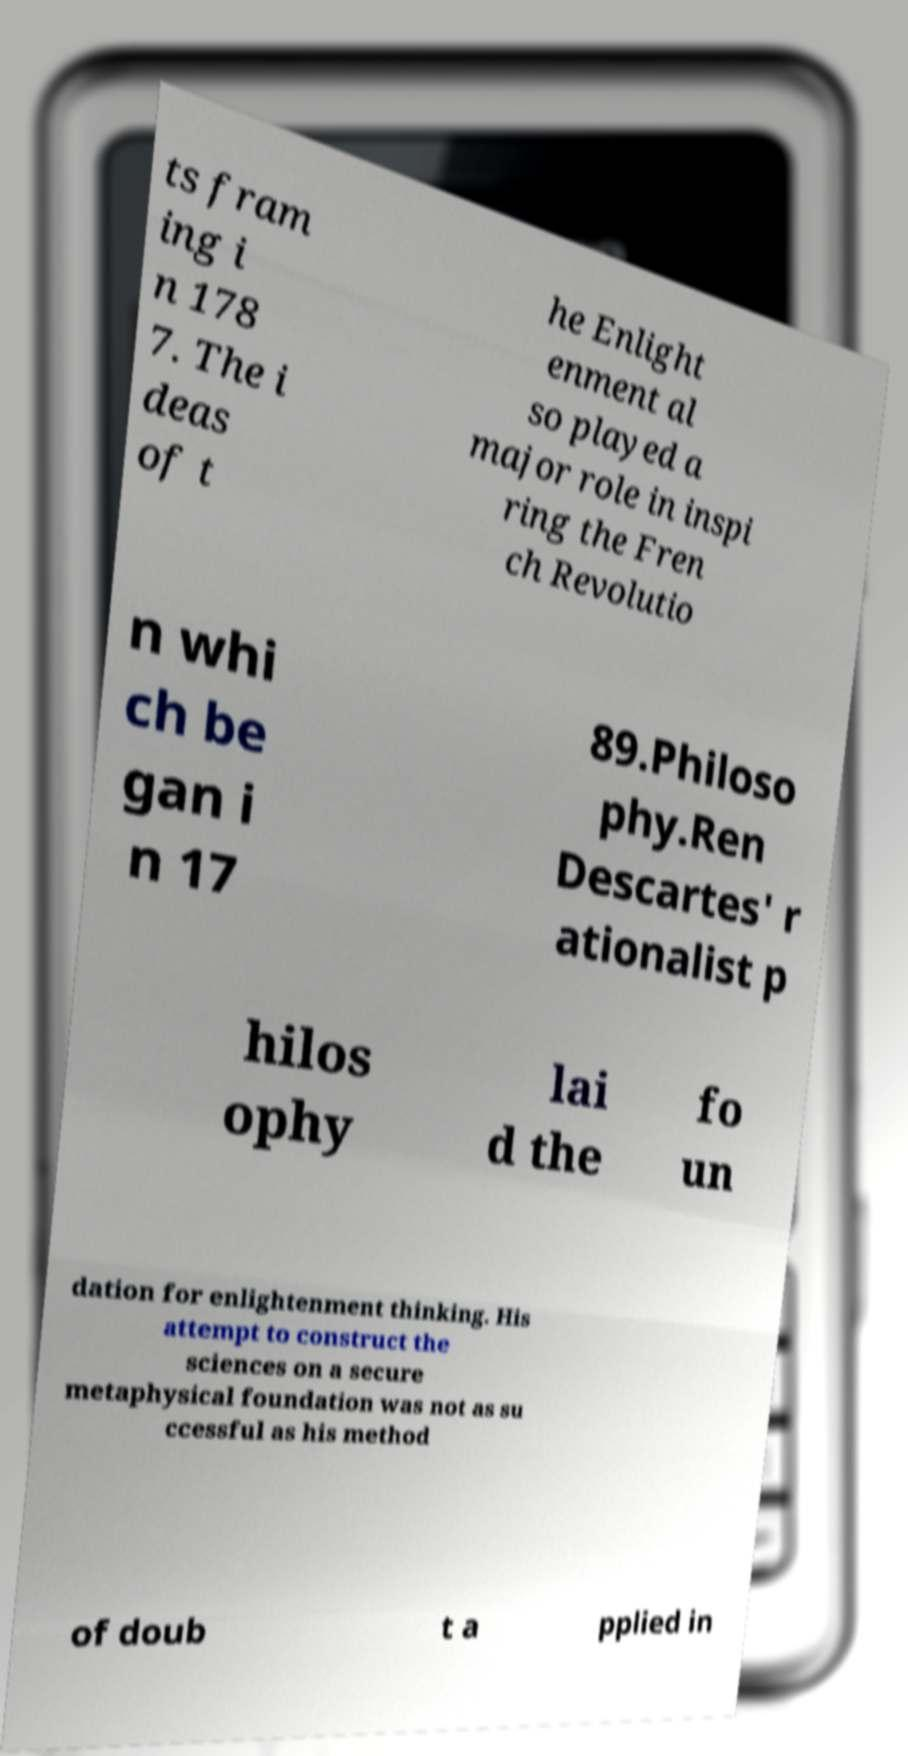Can you accurately transcribe the text from the provided image for me? ts fram ing i n 178 7. The i deas of t he Enlight enment al so played a major role in inspi ring the Fren ch Revolutio n whi ch be gan i n 17 89.Philoso phy.Ren Descartes' r ationalist p hilos ophy lai d the fo un dation for enlightenment thinking. His attempt to construct the sciences on a secure metaphysical foundation was not as su ccessful as his method of doub t a pplied in 